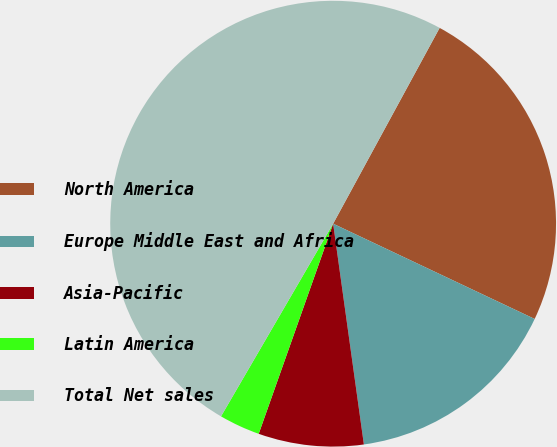Convert chart. <chart><loc_0><loc_0><loc_500><loc_500><pie_chart><fcel>North America<fcel>Europe Middle East and Africa<fcel>Asia-Pacific<fcel>Latin America<fcel>Total Net sales<nl><fcel>24.1%<fcel>15.77%<fcel>7.62%<fcel>2.97%<fcel>49.54%<nl></chart> 